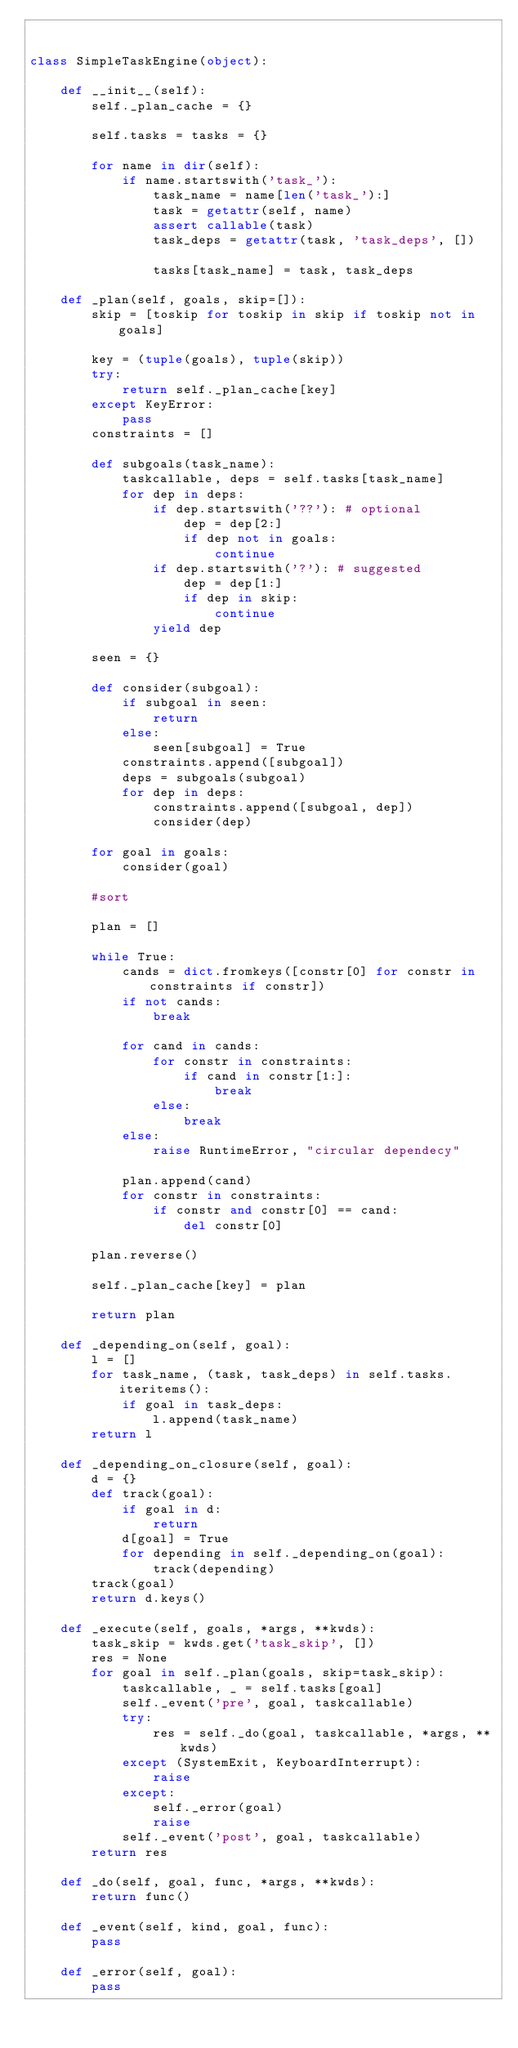Convert code to text. <code><loc_0><loc_0><loc_500><loc_500><_Python_>

class SimpleTaskEngine(object):

    def __init__(self):
        self._plan_cache = {}

        self.tasks = tasks = {}

        for name in dir(self):
            if name.startswith('task_'):
                task_name = name[len('task_'):]
                task = getattr(self, name)
                assert callable(task)
                task_deps = getattr(task, 'task_deps', [])

                tasks[task_name] = task, task_deps

    def _plan(self, goals, skip=[]):
        skip = [toskip for toskip in skip if toskip not in goals]

        key = (tuple(goals), tuple(skip))
        try:
            return self._plan_cache[key]
        except KeyError:
            pass
        constraints = []

        def subgoals(task_name):
            taskcallable, deps = self.tasks[task_name]
            for dep in deps:
                if dep.startswith('??'): # optional
                    dep = dep[2:]
                    if dep not in goals:
                        continue                
                if dep.startswith('?'): # suggested
                    dep = dep[1:]
                    if dep in skip:
                        continue
                yield dep

        seen = {}
                        
        def consider(subgoal):
            if subgoal in seen:
                return
            else:
                seen[subgoal] = True
            constraints.append([subgoal])
            deps = subgoals(subgoal)
            for dep in deps:
                constraints.append([subgoal, dep])
                consider(dep)

        for goal in goals:
            consider(goal)

        #sort

        plan = []

        while True:
            cands = dict.fromkeys([constr[0] for constr in constraints if constr])
            if not cands:
                break

            for cand in cands:
                for constr in constraints:
                    if cand in constr[1:]:
                        break
                else:
                    break
            else:
                raise RuntimeError, "circular dependecy"

            plan.append(cand)
            for constr in constraints:
                if constr and constr[0] == cand:
                    del constr[0]

        plan.reverse()

        self._plan_cache[key] = plan

        return plan

    def _depending_on(self, goal):
        l = []
        for task_name, (task, task_deps) in self.tasks.iteritems():
            if goal in task_deps:
                l.append(task_name)
        return l

    def _depending_on_closure(self, goal):
        d = {}
        def track(goal):
            if goal in d:
                return
            d[goal] = True
            for depending in self._depending_on(goal):
                track(depending)
        track(goal)
        return d.keys()

    def _execute(self, goals, *args, **kwds):
        task_skip = kwds.get('task_skip', [])
        res = None
        for goal in self._plan(goals, skip=task_skip):
            taskcallable, _ = self.tasks[goal]
            self._event('pre', goal, taskcallable)
            try:
                res = self._do(goal, taskcallable, *args, **kwds)
            except (SystemExit, KeyboardInterrupt):
                raise
            except:
                self._error(goal)
                raise
            self._event('post', goal, taskcallable)
        return res

    def _do(self, goal, func, *args, **kwds):
        return func()

    def _event(self, kind, goal, func):
        pass
    
    def _error(self, goal):
        pass


        
        
</code> 